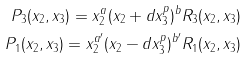<formula> <loc_0><loc_0><loc_500><loc_500>P _ { 3 } ( x _ { 2 } , x _ { 3 } ) = x _ { 2 } ^ { a } ( x _ { 2 } + d x _ { 3 } ^ { p } ) ^ { b } R _ { 3 } ( x _ { 2 } , x _ { 3 } ) \\ P _ { 1 } ( x _ { 2 } , x _ { 3 } ) = x _ { 2 } ^ { a ^ { \prime } } ( x _ { 2 } - d x _ { 3 } ^ { p } ) ^ { b ^ { \prime } } R _ { 1 } ( x _ { 2 } , x _ { 3 } )</formula> 